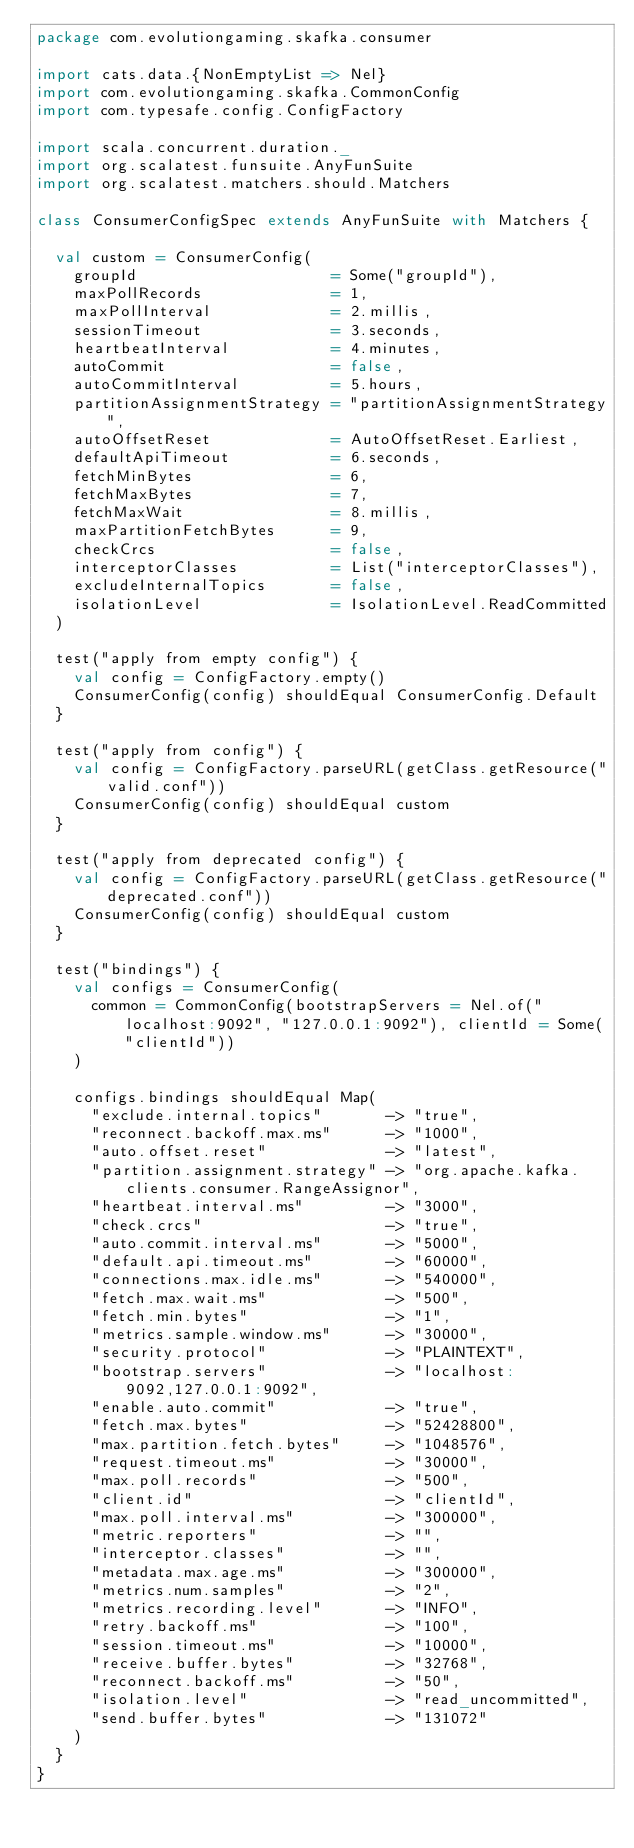Convert code to text. <code><loc_0><loc_0><loc_500><loc_500><_Scala_>package com.evolutiongaming.skafka.consumer

import cats.data.{NonEmptyList => Nel}
import com.evolutiongaming.skafka.CommonConfig
import com.typesafe.config.ConfigFactory

import scala.concurrent.duration._
import org.scalatest.funsuite.AnyFunSuite
import org.scalatest.matchers.should.Matchers

class ConsumerConfigSpec extends AnyFunSuite with Matchers {

  val custom = ConsumerConfig(
    groupId                     = Some("groupId"),
    maxPollRecords              = 1,
    maxPollInterval             = 2.millis,
    sessionTimeout              = 3.seconds,
    heartbeatInterval           = 4.minutes,
    autoCommit                  = false,
    autoCommitInterval          = 5.hours,
    partitionAssignmentStrategy = "partitionAssignmentStrategy",
    autoOffsetReset             = AutoOffsetReset.Earliest,
    defaultApiTimeout           = 6.seconds,
    fetchMinBytes               = 6,
    fetchMaxBytes               = 7,
    fetchMaxWait                = 8.millis,
    maxPartitionFetchBytes      = 9,
    checkCrcs                   = false,
    interceptorClasses          = List("interceptorClasses"),
    excludeInternalTopics       = false,
    isolationLevel              = IsolationLevel.ReadCommitted
  )

  test("apply from empty config") {
    val config = ConfigFactory.empty()
    ConsumerConfig(config) shouldEqual ConsumerConfig.Default
  }

  test("apply from config") {
    val config = ConfigFactory.parseURL(getClass.getResource("valid.conf"))
    ConsumerConfig(config) shouldEqual custom
  }

  test("apply from deprecated config") {
    val config = ConfigFactory.parseURL(getClass.getResource("deprecated.conf"))
    ConsumerConfig(config) shouldEqual custom
  }

  test("bindings") {
    val configs = ConsumerConfig(
      common = CommonConfig(bootstrapServers = Nel.of("localhost:9092", "127.0.0.1:9092"), clientId = Some("clientId"))
    )

    configs.bindings shouldEqual Map(
      "exclude.internal.topics"       -> "true",
      "reconnect.backoff.max.ms"      -> "1000",
      "auto.offset.reset"             -> "latest",
      "partition.assignment.strategy" -> "org.apache.kafka.clients.consumer.RangeAssignor",
      "heartbeat.interval.ms"         -> "3000",
      "check.crcs"                    -> "true",
      "auto.commit.interval.ms"       -> "5000",
      "default.api.timeout.ms"        -> "60000",
      "connections.max.idle.ms"       -> "540000",
      "fetch.max.wait.ms"             -> "500",
      "fetch.min.bytes"               -> "1",
      "metrics.sample.window.ms"      -> "30000",
      "security.protocol"             -> "PLAINTEXT",
      "bootstrap.servers"             -> "localhost:9092,127.0.0.1:9092",
      "enable.auto.commit"            -> "true",
      "fetch.max.bytes"               -> "52428800",
      "max.partition.fetch.bytes"     -> "1048576",
      "request.timeout.ms"            -> "30000",
      "max.poll.records"              -> "500",
      "client.id"                     -> "clientId",
      "max.poll.interval.ms"          -> "300000",
      "metric.reporters"              -> "",
      "interceptor.classes"           -> "",
      "metadata.max.age.ms"           -> "300000",
      "metrics.num.samples"           -> "2",
      "metrics.recording.level"       -> "INFO",
      "retry.backoff.ms"              -> "100",
      "session.timeout.ms"            -> "10000",
      "receive.buffer.bytes"          -> "32768",
      "reconnect.backoff.ms"          -> "50",
      "isolation.level"               -> "read_uncommitted",
      "send.buffer.bytes"             -> "131072"
    )
  }
}
</code> 